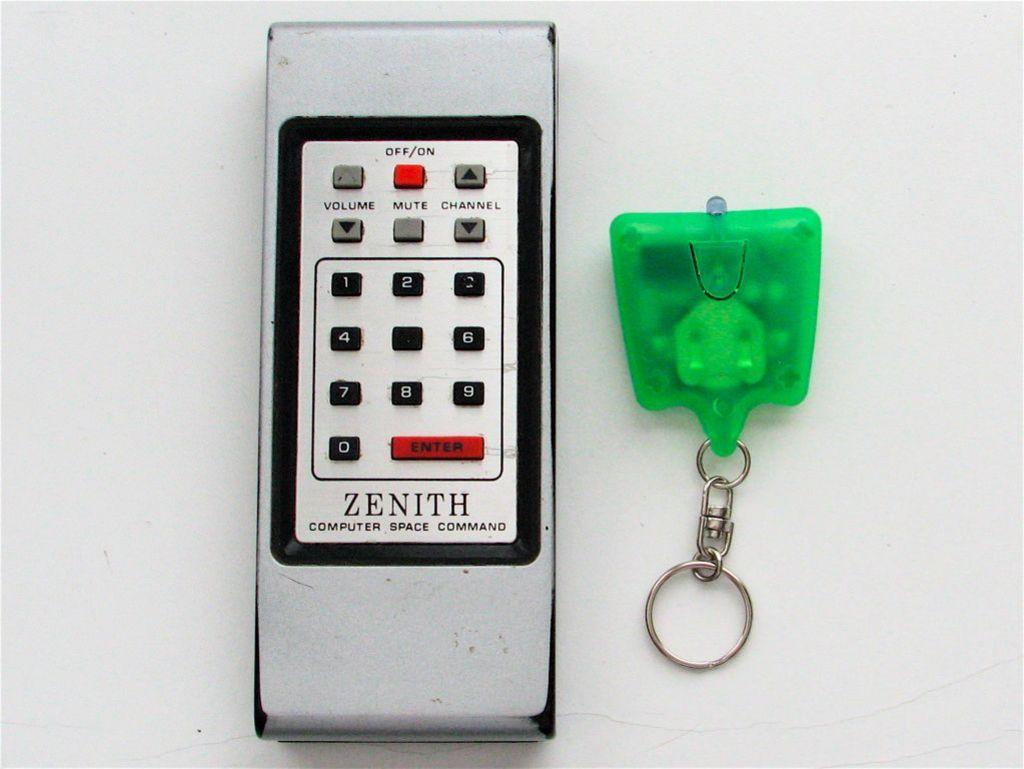Provide a one-sentence caption for the provided image. A Zenith television remote sits next to a green keychain. 